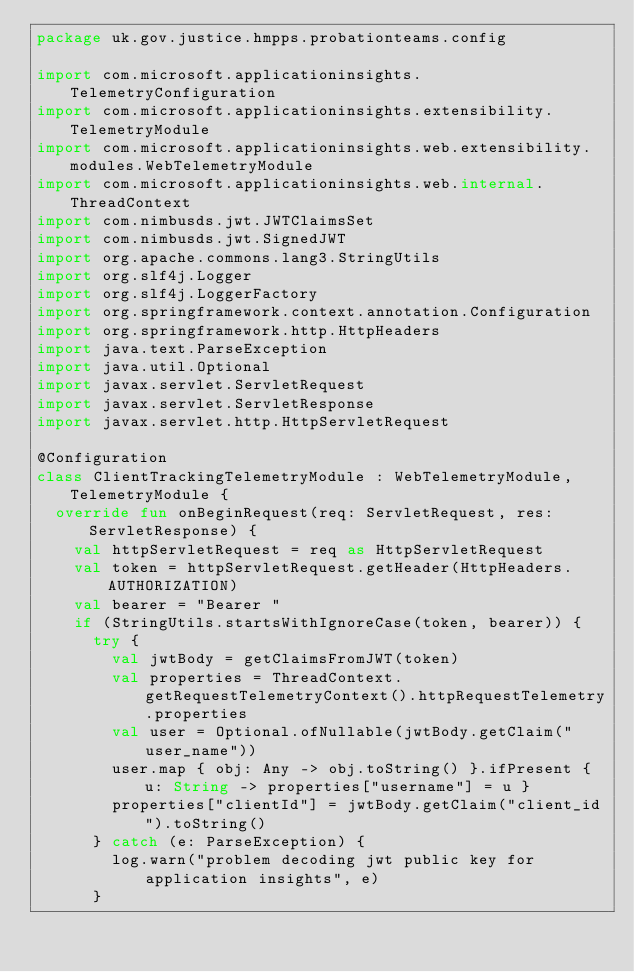Convert code to text. <code><loc_0><loc_0><loc_500><loc_500><_Kotlin_>package uk.gov.justice.hmpps.probationteams.config

import com.microsoft.applicationinsights.TelemetryConfiguration
import com.microsoft.applicationinsights.extensibility.TelemetryModule
import com.microsoft.applicationinsights.web.extensibility.modules.WebTelemetryModule
import com.microsoft.applicationinsights.web.internal.ThreadContext
import com.nimbusds.jwt.JWTClaimsSet
import com.nimbusds.jwt.SignedJWT
import org.apache.commons.lang3.StringUtils
import org.slf4j.Logger
import org.slf4j.LoggerFactory
import org.springframework.context.annotation.Configuration
import org.springframework.http.HttpHeaders
import java.text.ParseException
import java.util.Optional
import javax.servlet.ServletRequest
import javax.servlet.ServletResponse
import javax.servlet.http.HttpServletRequest

@Configuration
class ClientTrackingTelemetryModule : WebTelemetryModule, TelemetryModule {
  override fun onBeginRequest(req: ServletRequest, res: ServletResponse) {
    val httpServletRequest = req as HttpServletRequest
    val token = httpServletRequest.getHeader(HttpHeaders.AUTHORIZATION)
    val bearer = "Bearer "
    if (StringUtils.startsWithIgnoreCase(token, bearer)) {
      try {
        val jwtBody = getClaimsFromJWT(token)
        val properties = ThreadContext.getRequestTelemetryContext().httpRequestTelemetry.properties
        val user = Optional.ofNullable(jwtBody.getClaim("user_name"))
        user.map { obj: Any -> obj.toString() }.ifPresent { u: String -> properties["username"] = u }
        properties["clientId"] = jwtBody.getClaim("client_id").toString()
      } catch (e: ParseException) {
        log.warn("problem decoding jwt public key for application insights", e)
      }</code> 